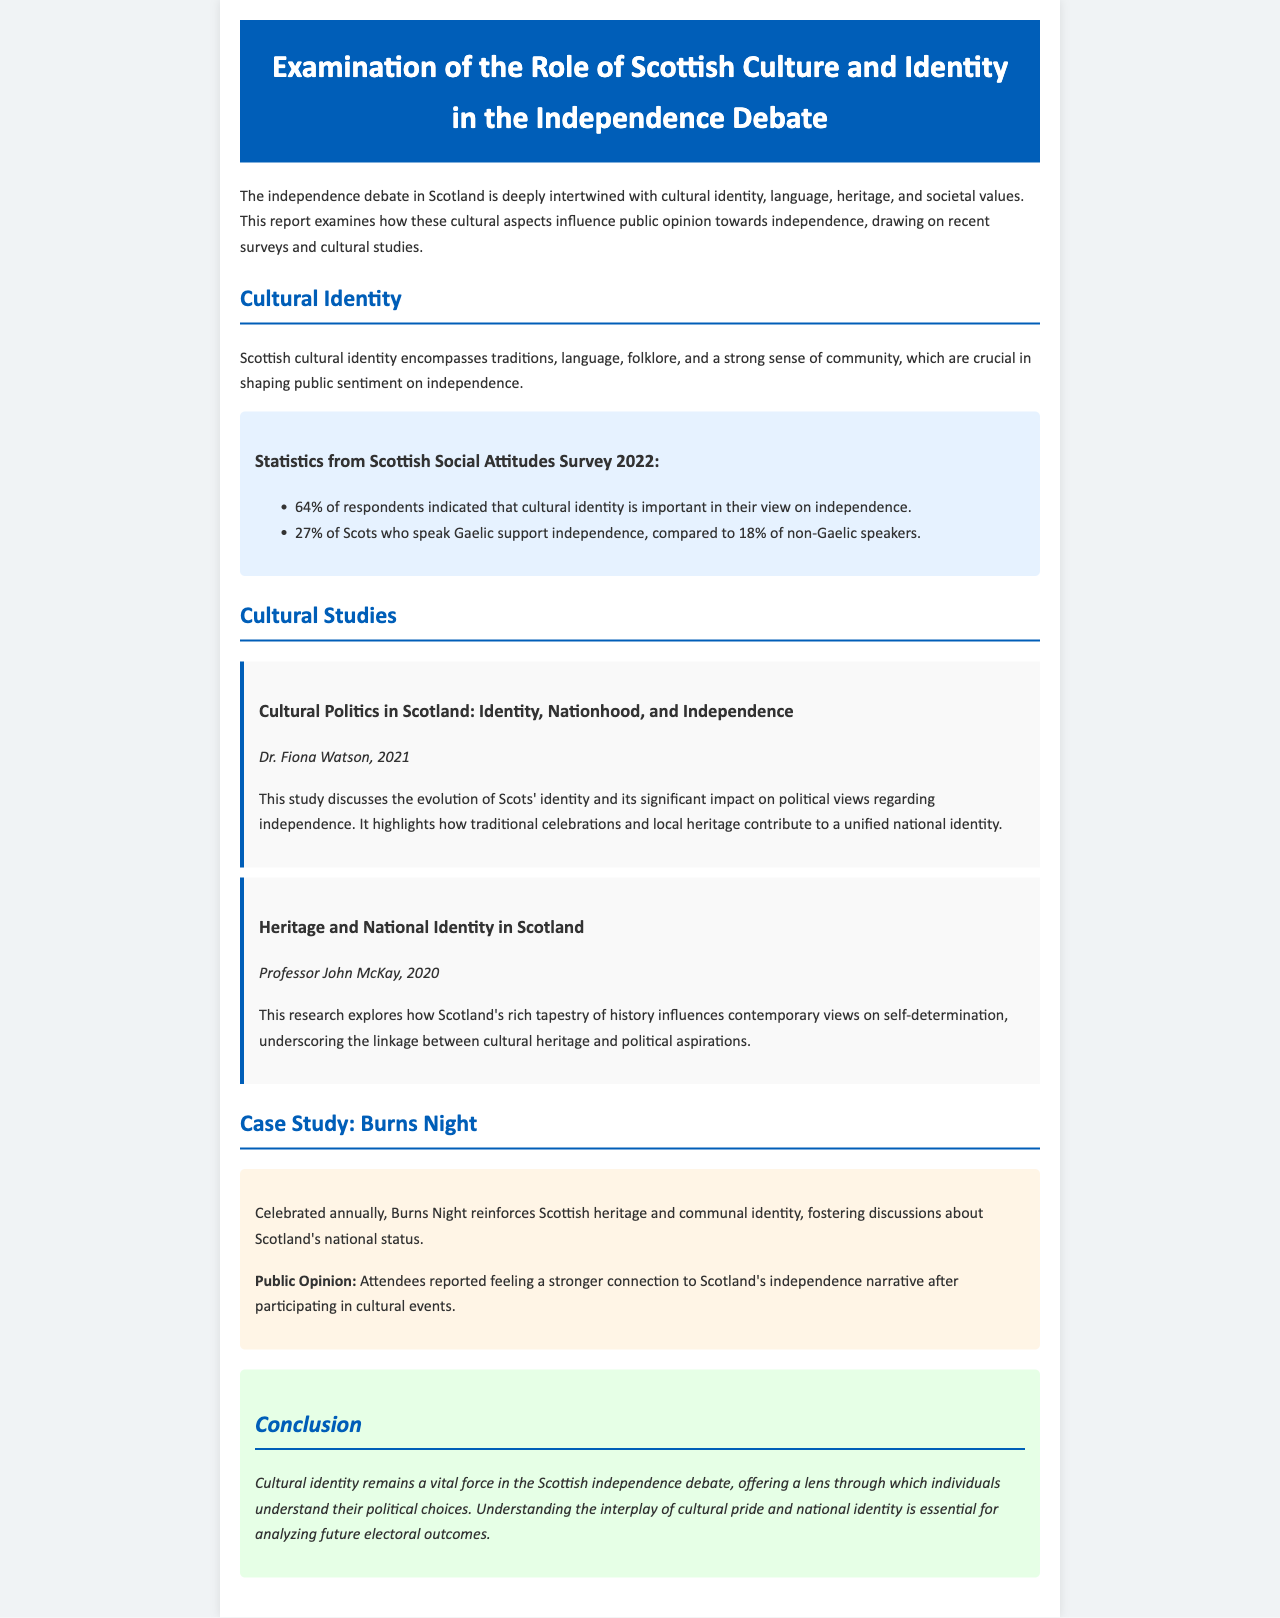What percentage of respondents indicated that cultural identity is important in their view on independence? The report states that 64% of respondents indicated that cultural identity is important in their view on independence.
Answer: 64% What is the name of Dr. Fiona Watson's study? The study conducted by Dr. Fiona Watson is titled "Cultural Politics in Scotland: Identity, Nationhood, and Independence."
Answer: Cultural Politics in Scotland: Identity, Nationhood, and Independence What year did Professor John McKay conduct his research? The research by Professor John McKay was conducted in the year 2020.
Answer: 2020 What was the percentage of Scots who support independence among Gaelic speakers? The document mentions that 27% of Scots who speak Gaelic support independence.
Answer: 27% What cultural event is highlighted as a case study in the report? Burns Night is cited as a significant cultural event in the case study section of the report.
Answer: Burns Night How does participation in cultural events affect public opinion on independence? The report mentions that attendees reported feeling a stronger connection to Scotland's independence narrative after participating in cultural events.
Answer: Stronger connection What is the primary focus of the conclusion in the document? The conclusion emphasizes the vital role of cultural identity in understanding political choices related to the independence debate.
Answer: Cultural identity What percentage of non-Gaelic speakers support independence? According to the document, 18% of non-Gaelic speakers support independence.
Answer: 18% 